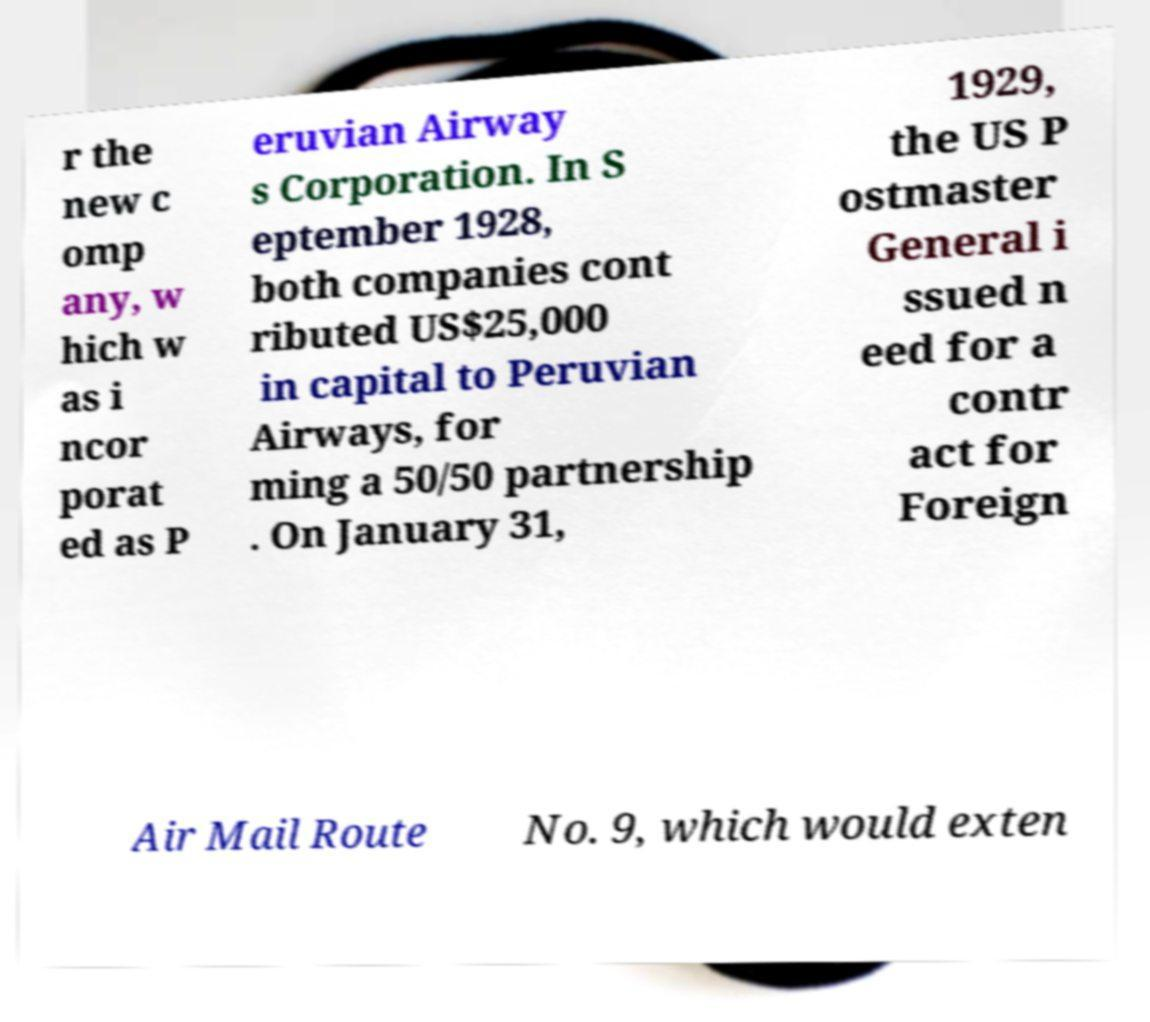Please identify and transcribe the text found in this image. r the new c omp any, w hich w as i ncor porat ed as P eruvian Airway s Corporation. In S eptember 1928, both companies cont ributed US$25,000 in capital to Peruvian Airways, for ming a 50/50 partnership . On January 31, 1929, the US P ostmaster General i ssued n eed for a contr act for Foreign Air Mail Route No. 9, which would exten 